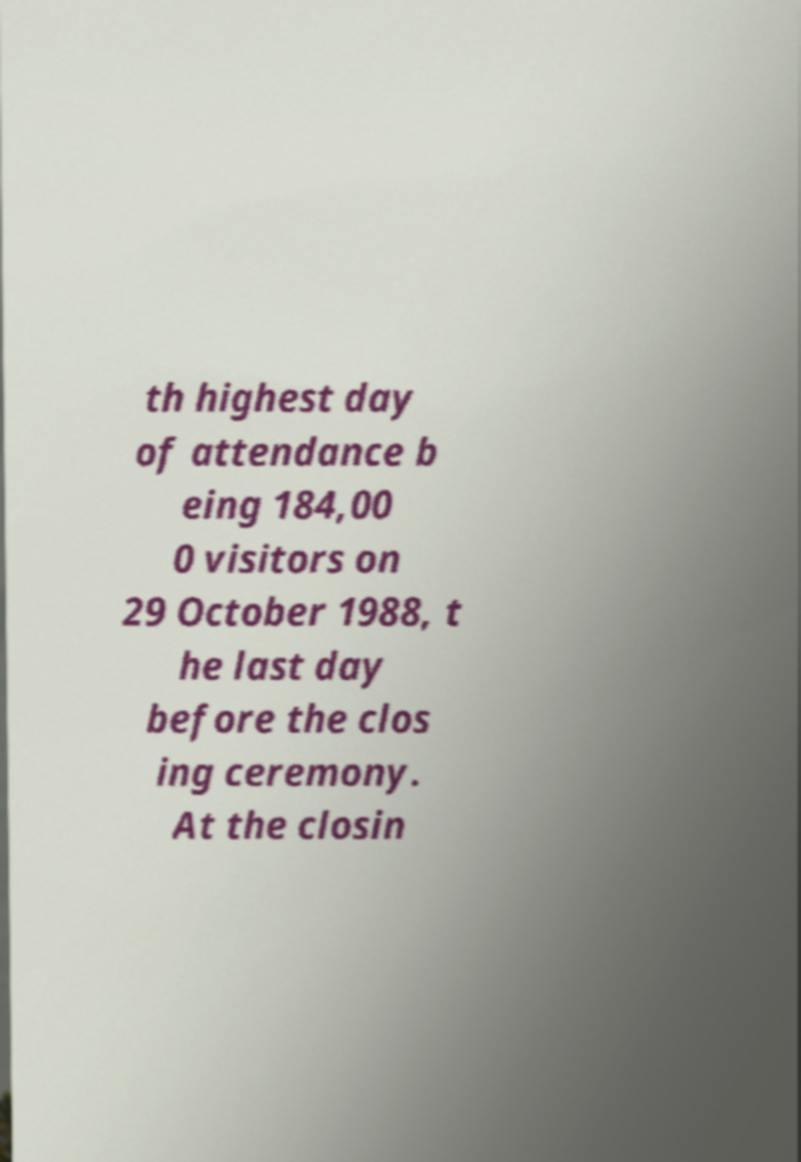I need the written content from this picture converted into text. Can you do that? th highest day of attendance b eing 184,00 0 visitors on 29 October 1988, t he last day before the clos ing ceremony. At the closin 